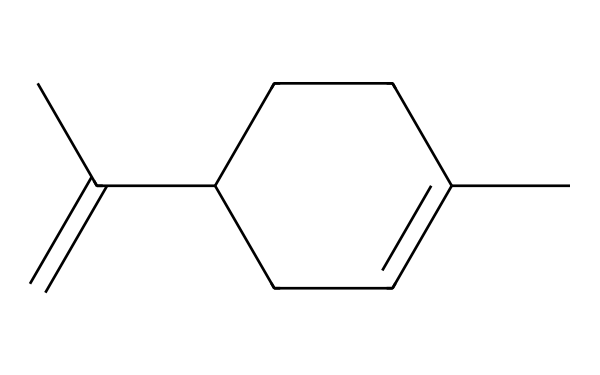What is the molecular formula of limonene? To determine the molecular formula, we count the number of each type of atom in the SMILES representation. From the given SMILES, we have 10 carbon atoms and 16 hydrogen atoms, resulting in the molecular formula C10H16.
Answer: C10H16 How many double bonds are present in limonene? By analyzing the structure indicated by the SMILES, we observe one double bond between the carbon atoms in the ring and one double bond in the terminal part of the chain. Thus, there are 2 double bonds in total.
Answer: 2 What type of organic compound is limonene classified as? Limonene is classified as a monoterpene due to its bicyclic structure and its classification in the terpene family (specifically a cyclic compound from terpenes).
Answer: monoterpene Is limonene a saturated or unsaturated compound? Since limonene contains double bonds, it is classified as unsaturated. Unsaturated compounds have one or more double or triple bonds in their molecular structure.
Answer: unsaturated How many rings are present in the limonene structure? The SMILES shows that limonene has a single ring structure, which is typical for monoterpenes. We identify the ring by looking for the numeric indicators (the '1' in this case signifies the start and end of a ring).
Answer: 1 What is the significance of limonene's structure in fragrances? Limonene’s structure, particularly its cyclic arrangement and double bonds, contributes to its volatility and pleasant citrus scent, which are essential for its use in fragrances and cleaning products.
Answer: volatility and scent 